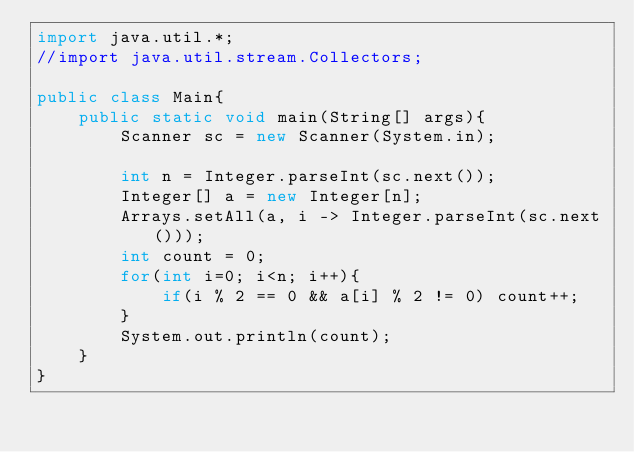<code> <loc_0><loc_0><loc_500><loc_500><_Java_>import java.util.*;
//import java.util.stream.Collectors;

public class Main{
	public static void main(String[] args){
		Scanner sc = new Scanner(System.in);
		
		int n = Integer.parseInt(sc.next());
		Integer[] a = new Integer[n];
		Arrays.setAll(a, i -> Integer.parseInt(sc.next()));
		int count = 0;
		for(int i=0; i<n; i++){
			if(i % 2 == 0 && a[i] % 2 != 0) count++;
		}
		System.out.println(count);
	}
}
</code> 